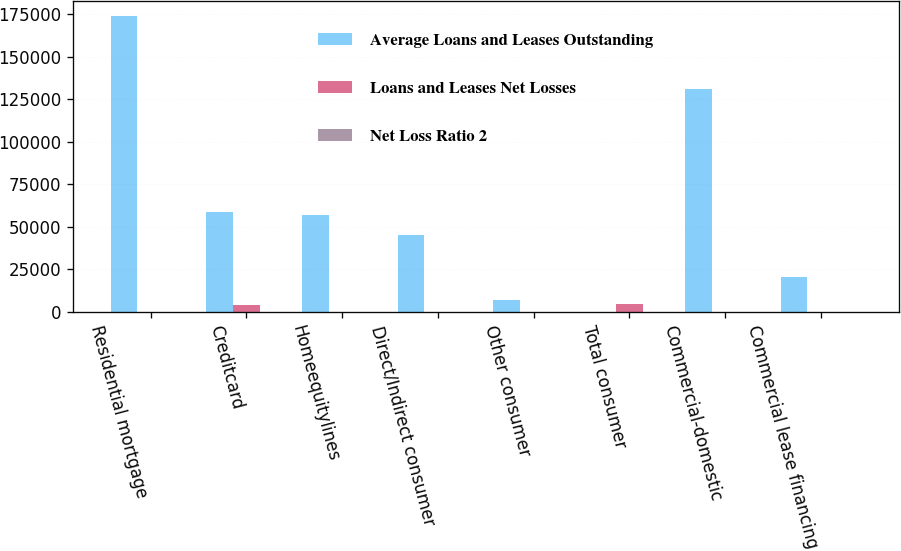Convert chart. <chart><loc_0><loc_0><loc_500><loc_500><stacked_bar_chart><ecel><fcel>Residential mortgage<fcel>Creditcard<fcel>Homeequitylines<fcel>Direct/Indirect consumer<fcel>Other consumer<fcel>Total consumer<fcel>Commercial-domestic<fcel>Commercial lease financing<nl><fcel>Average Loans and Leases Outstanding<fcel>173773<fcel>59048<fcel>56842<fcel>44981<fcel>6908<fcel>231<fcel>130870<fcel>20441<nl><fcel>Loans and Leases Net Losses<fcel>27<fcel>4086<fcel>31<fcel>248<fcel>275<fcel>4667<fcel>157<fcel>231<nl><fcel>Net Loss Ratio 2<fcel>0.02<fcel>6.92<fcel>0.05<fcel>0.55<fcel>3.98<fcel>1.37<fcel>0.12<fcel>1.13<nl></chart> 